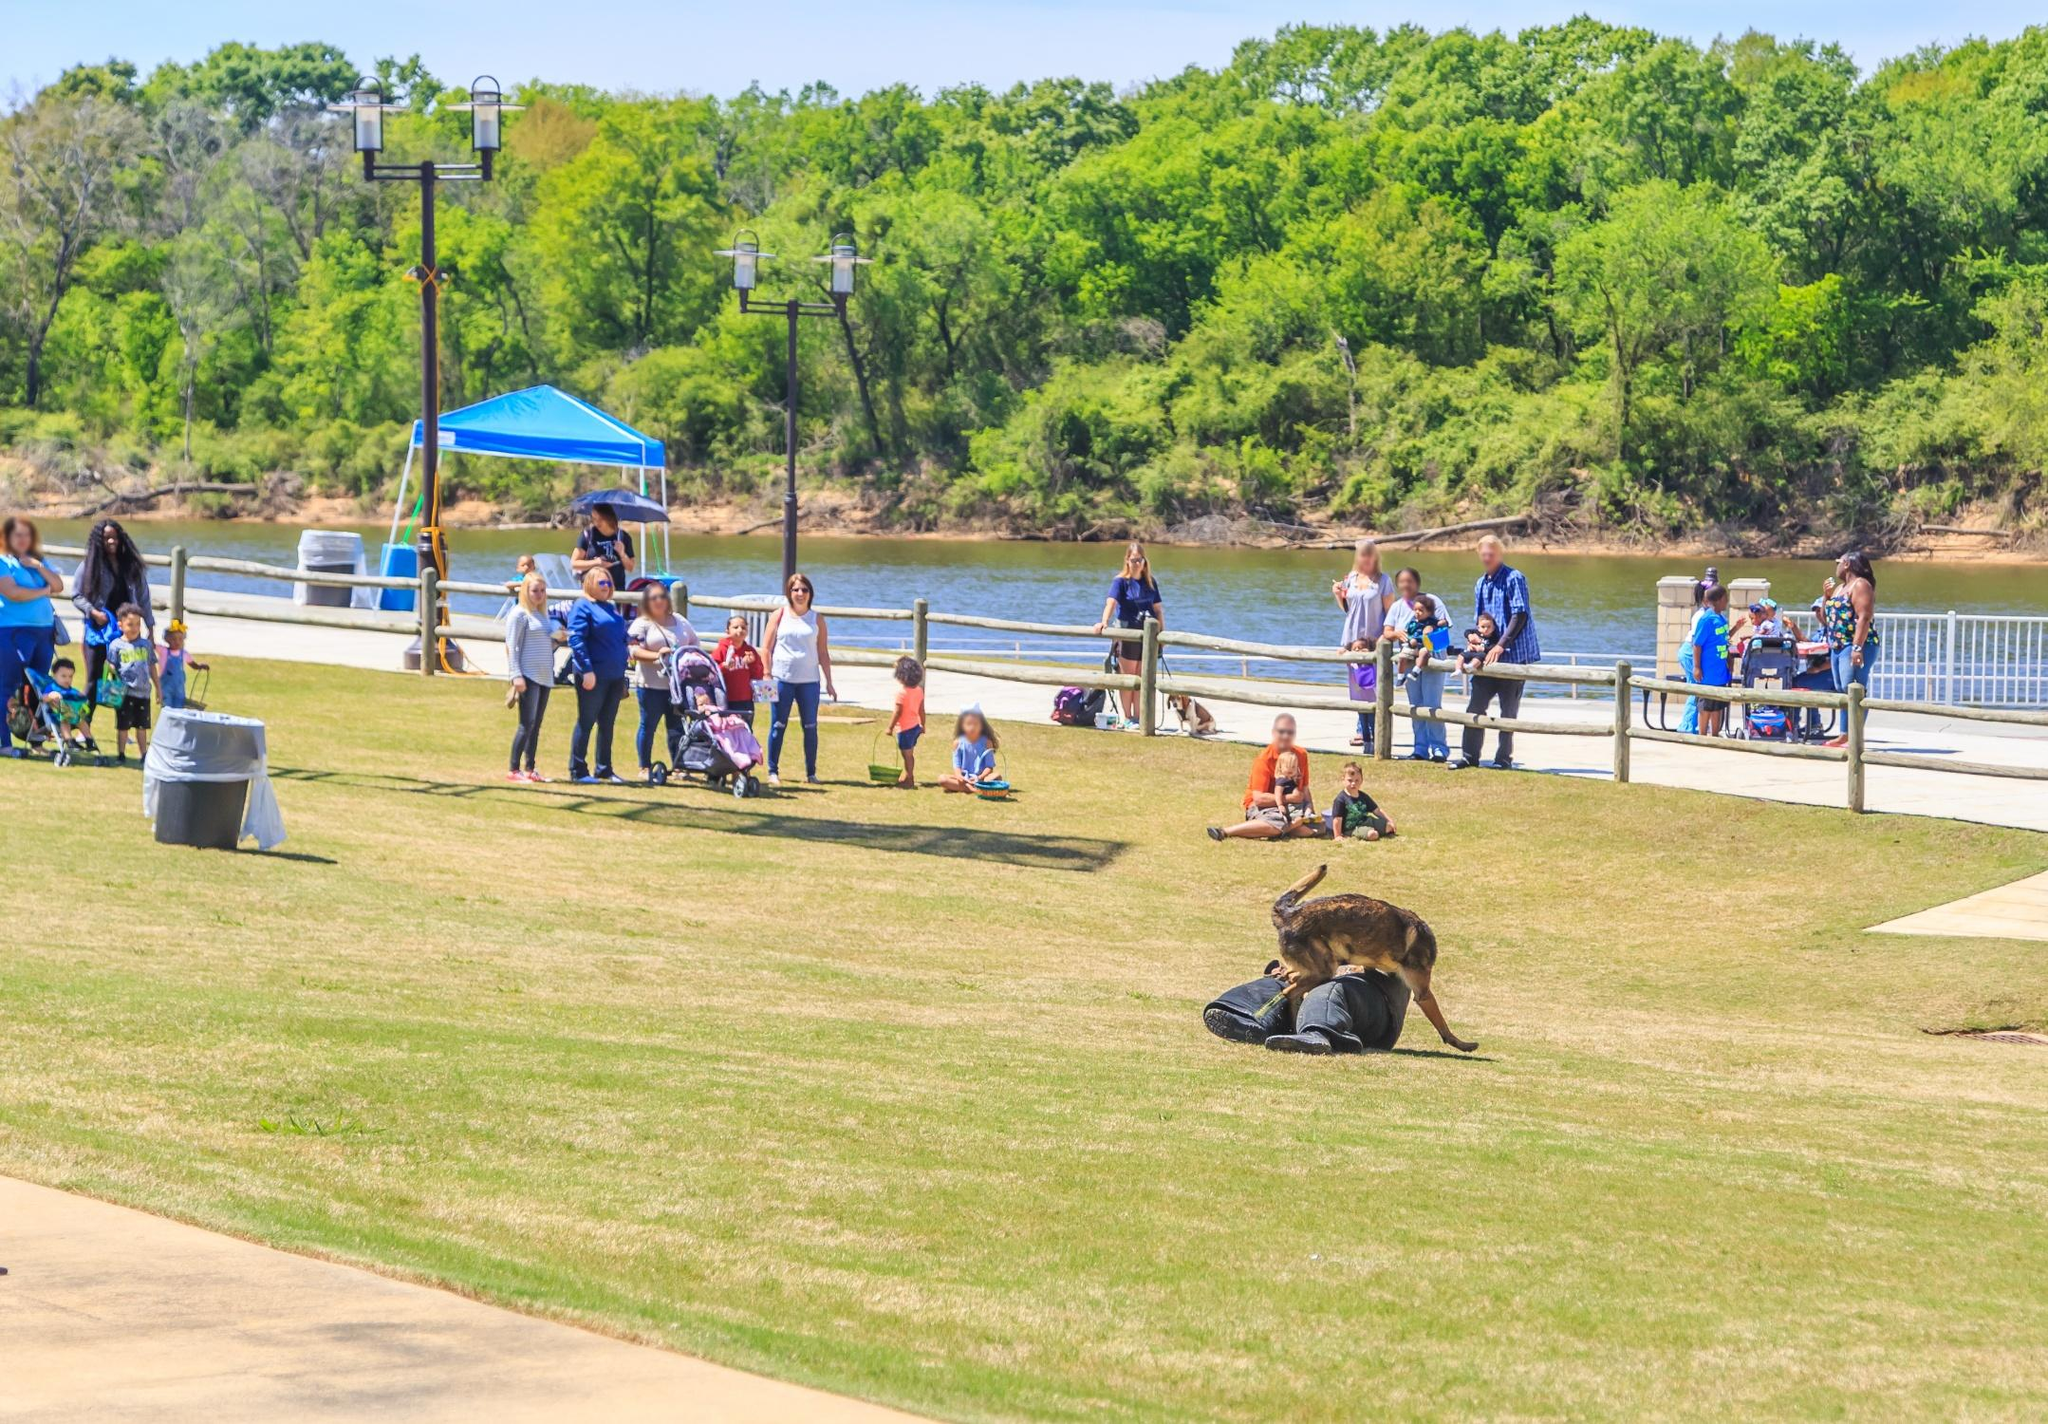Write a short story inspired by this park scene. Liam was excited as his family set up their spot under the blue canopy near the river. He loved weekends spent at the park, where he could meet friends and explore. Today, he noticed a dog curiously sniffing a backpack nearby. He approached slowly, hoping to make a new furry friend. The dog's tail wagged energetically as if inviting him to join the fun. Moments later, a group of children gathered around, turning the park into a haven of laughter and playful energy. Liam felt a deep sense of happiness, realizing that these simple, joyful moments would become cherished memories. 